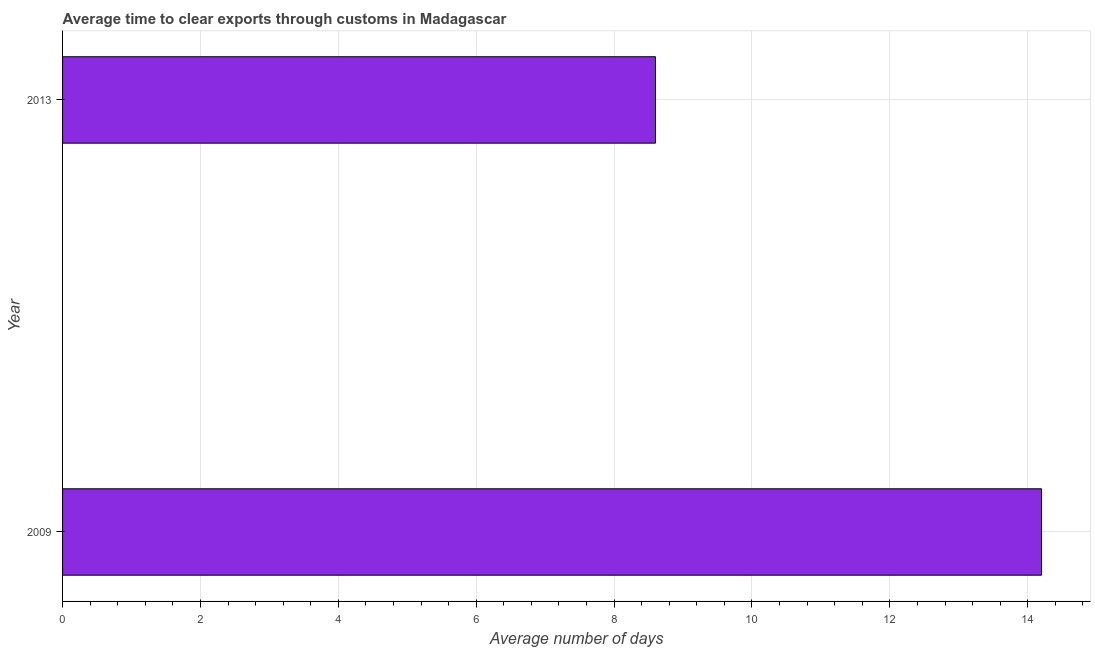Does the graph contain any zero values?
Provide a short and direct response. No. What is the title of the graph?
Your answer should be compact. Average time to clear exports through customs in Madagascar. What is the label or title of the X-axis?
Offer a very short reply. Average number of days. What is the time to clear exports through customs in 2009?
Keep it short and to the point. 14.2. Across all years, what is the maximum time to clear exports through customs?
Your answer should be very brief. 14.2. What is the sum of the time to clear exports through customs?
Provide a short and direct response. 22.8. What is the difference between the time to clear exports through customs in 2009 and 2013?
Give a very brief answer. 5.6. What is the median time to clear exports through customs?
Provide a succinct answer. 11.4. What is the ratio of the time to clear exports through customs in 2009 to that in 2013?
Offer a very short reply. 1.65. In how many years, is the time to clear exports through customs greater than the average time to clear exports through customs taken over all years?
Offer a very short reply. 1. How many bars are there?
Ensure brevity in your answer.  2. What is the difference between two consecutive major ticks on the X-axis?
Make the answer very short. 2. Are the values on the major ticks of X-axis written in scientific E-notation?
Keep it short and to the point. No. What is the Average number of days of 2009?
Give a very brief answer. 14.2. What is the Average number of days of 2013?
Keep it short and to the point. 8.6. What is the difference between the Average number of days in 2009 and 2013?
Provide a succinct answer. 5.6. What is the ratio of the Average number of days in 2009 to that in 2013?
Give a very brief answer. 1.65. 